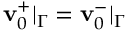Convert formula to latex. <formula><loc_0><loc_0><loc_500><loc_500>v _ { 0 } ^ { + } | _ { \Gamma } = v _ { 0 } ^ { - } | _ { \Gamma }</formula> 